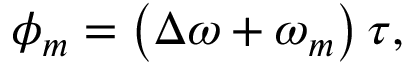Convert formula to latex. <formula><loc_0><loc_0><loc_500><loc_500>\phi _ { m } = \left ( \Delta \omega + \omega _ { m } \right ) \tau ,</formula> 